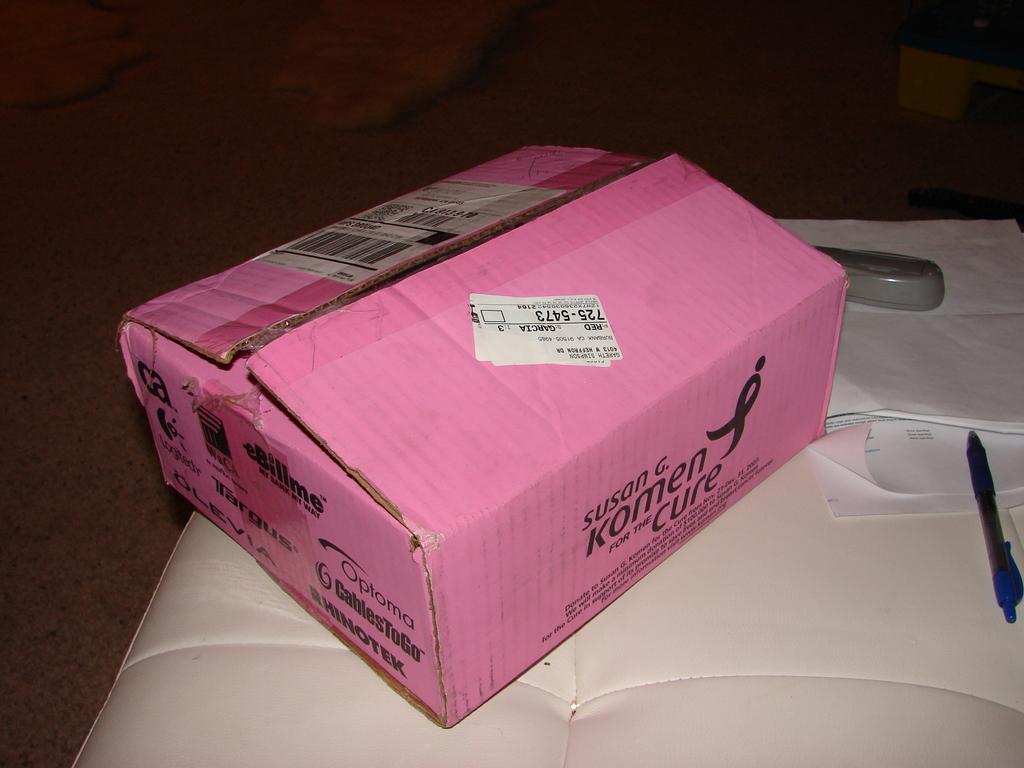Provide a one-sentence caption for the provided image. A pink opened box for the Susan G. Komen for the Cure laying on top of a white cushion. 